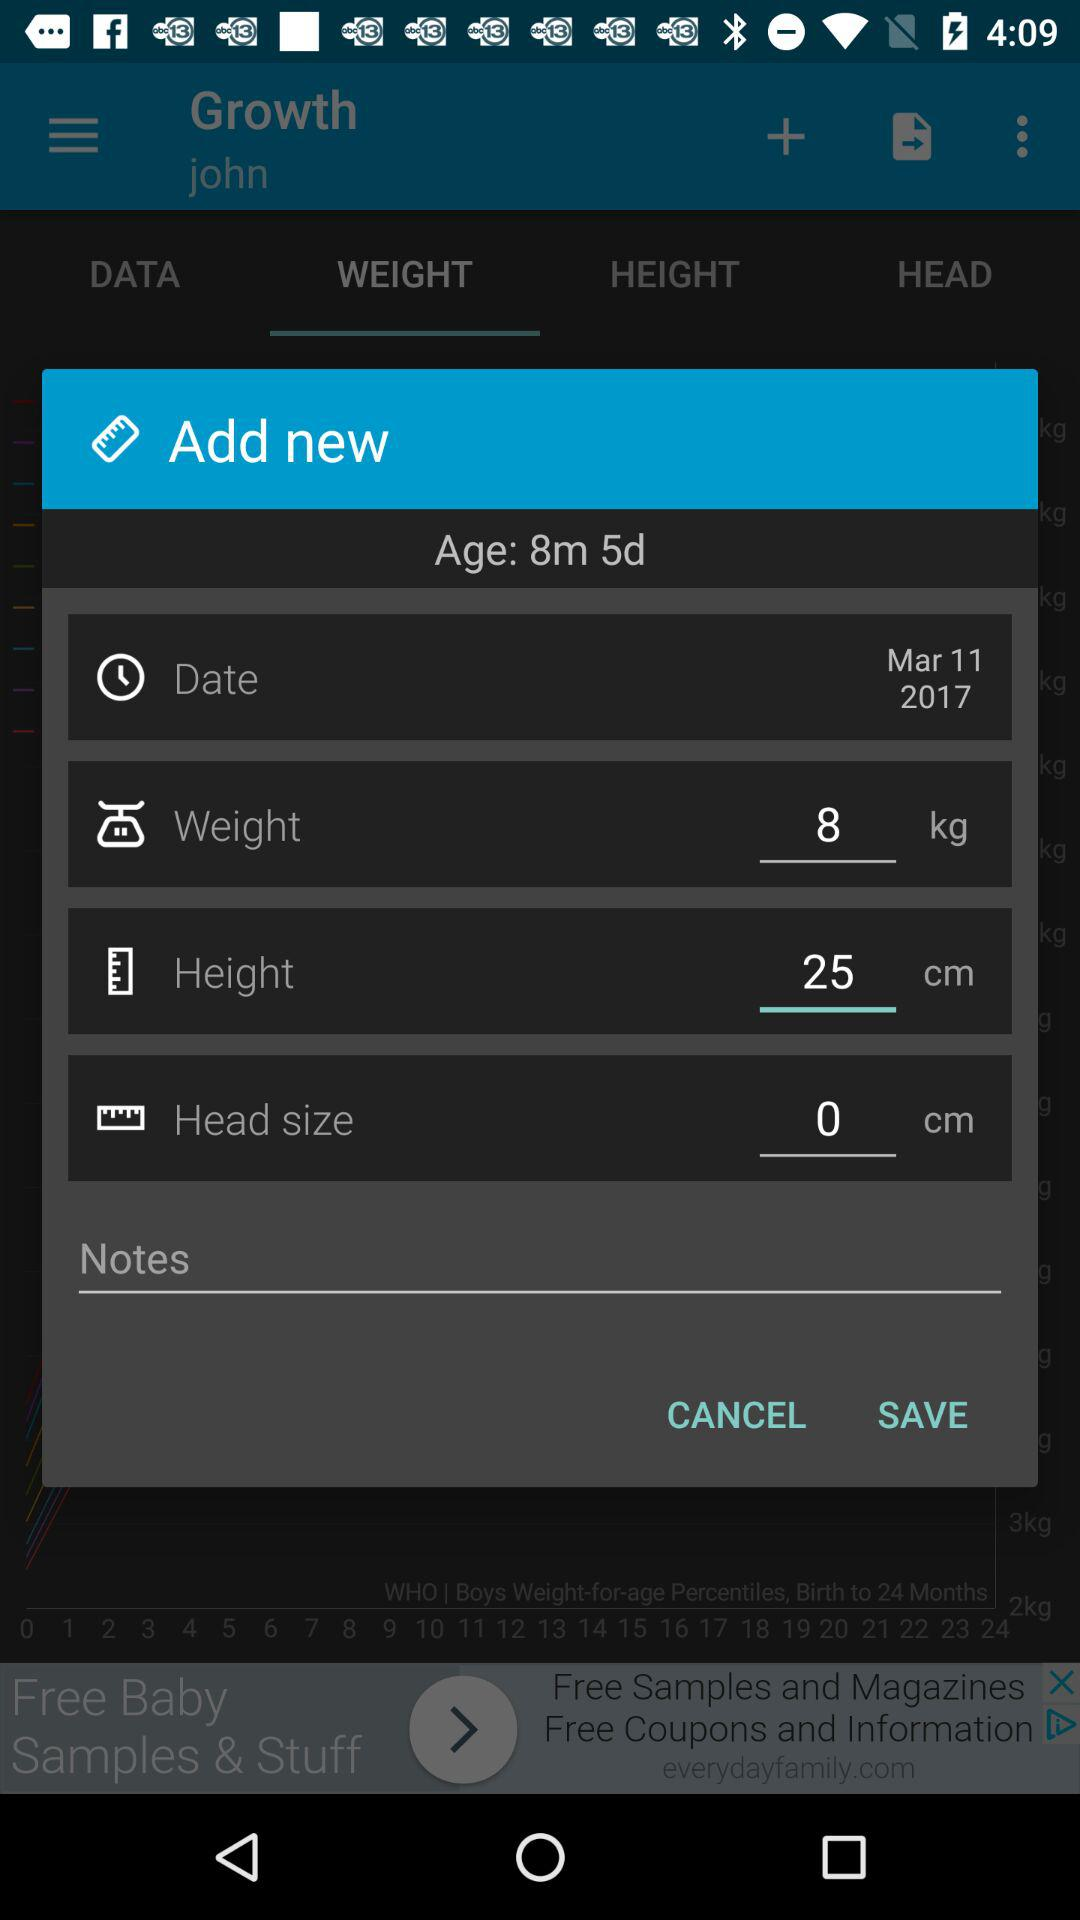How many more centimeters is the baby's height than their head size?
Answer the question using a single word or phrase. 25 